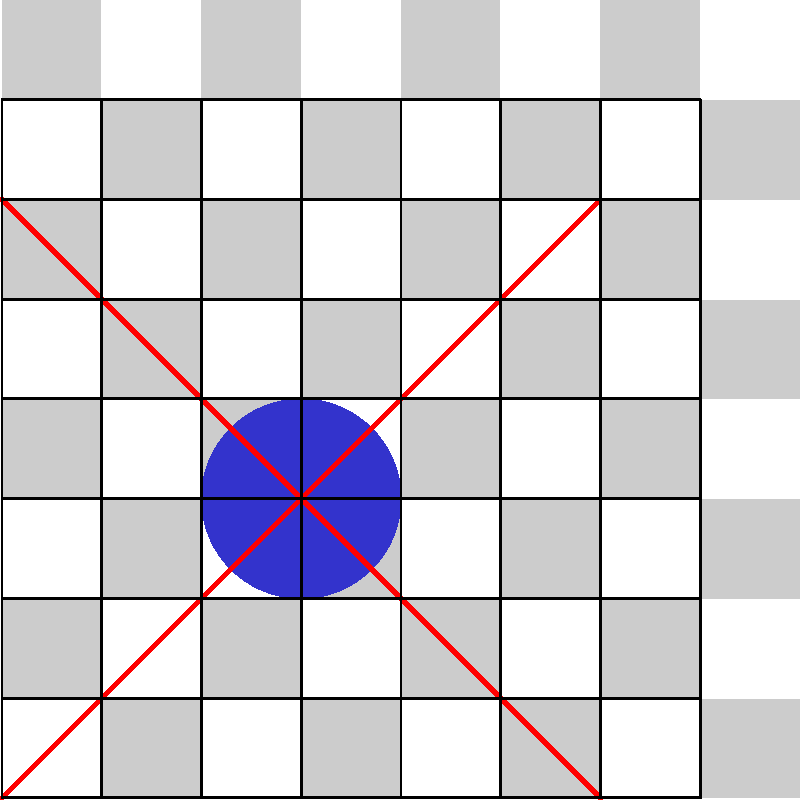In a chess-like game with an 8x8 board, a unique piece is placed at the center of the board (position D4). This piece can move diagonally in any direction for any number of squares in a single move. How many different squares can this piece reach in one move from its current position? To determine the number of squares this piece can reach, let's break it down step-by-step:

1) The piece can move diagonally in four directions:
   - Top-left to bottom-right
   - Top-right to bottom-left

2) In the top-left to bottom-right diagonal:
   - Moving upwards: 3 squares (E5, F6, G7)
   - Moving downwards: 3 squares (C3, B2, A1)

3) In the top-right to bottom-left diagonal:
   - Moving upwards: 3 squares (C5, B6, A7)
   - Moving downwards: 3 squares (E3, F2, G1)

4) Total number of reachable squares:
   $3 + 3 + 3 + 3 = 12$

Therefore, from its current position, the piece can reach 12 different squares in one move.
Answer: 12 squares 